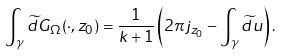<formula> <loc_0><loc_0><loc_500><loc_500>\int _ { \gamma } \widetilde { d } G _ { \Omega } ( \cdot , z _ { 0 } ) = \frac { 1 } { k + 1 } \left ( 2 \pi j _ { z _ { 0 } } - \int _ { \gamma } \widetilde { d } u \right ) .</formula> 